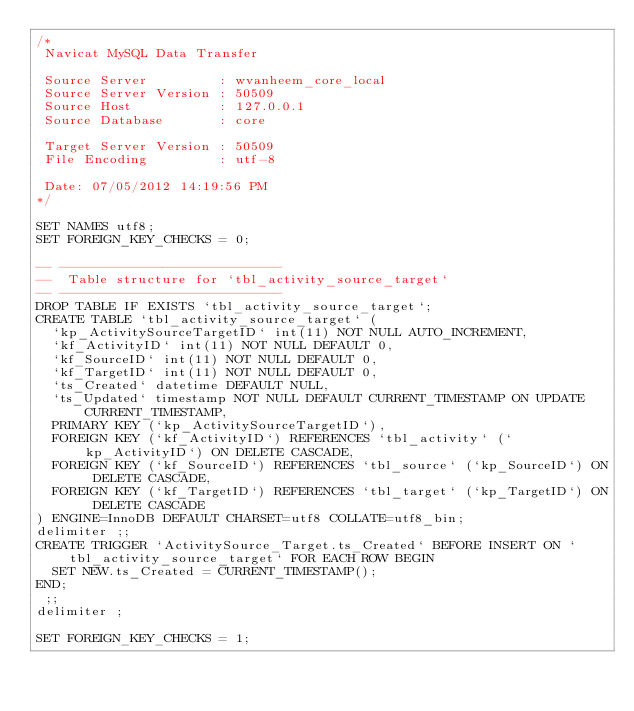Convert code to text. <code><loc_0><loc_0><loc_500><loc_500><_SQL_>/*
 Navicat MySQL Data Transfer

 Source Server         : wvanheem_core_local
 Source Server Version : 50509
 Source Host           : 127.0.0.1
 Source Database       : core

 Target Server Version : 50509
 File Encoding         : utf-8

 Date: 07/05/2012 14:19:56 PM
*/

SET NAMES utf8;
SET FOREIGN_KEY_CHECKS = 0;

-- ----------------------------
--  Table structure for `tbl_activity_source_target`
-- ----------------------------
DROP TABLE IF EXISTS `tbl_activity_source_target`;
CREATE TABLE `tbl_activity_source_target` (
  `kp_ActivitySourceTargetID` int(11) NOT NULL AUTO_INCREMENT,
  `kf_ActivityID` int(11) NOT NULL DEFAULT 0,  
  `kf_SourceID` int(11) NOT NULL DEFAULT 0,
  `kf_TargetID` int(11) NOT NULL DEFAULT 0,
  `ts_Created` datetime DEFAULT NULL,
  `ts_Updated` timestamp NOT NULL DEFAULT CURRENT_TIMESTAMP ON UPDATE CURRENT_TIMESTAMP,
  PRIMARY KEY (`kp_ActivitySourceTargetID`),
  FOREIGN KEY (`kf_ActivityID`) REFERENCES `tbl_activity` (`kp_ActivityID`) ON DELETE CASCADE,  
  FOREIGN KEY (`kf_SourceID`) REFERENCES `tbl_source` (`kp_SourceID`) ON DELETE CASCADE,
  FOREIGN KEY (`kf_TargetID`) REFERENCES `tbl_target` (`kp_TargetID`) ON DELETE CASCADE
) ENGINE=InnoDB DEFAULT CHARSET=utf8 COLLATE=utf8_bin;
delimiter ;;
CREATE TRIGGER `ActivitySource_Target.ts_Created` BEFORE INSERT ON `tbl_activity_source_target` FOR EACH ROW BEGIN
	SET NEW.ts_Created = CURRENT_TIMESTAMP();
END;
 ;;
delimiter ;

SET FOREIGN_KEY_CHECKS = 1;
</code> 